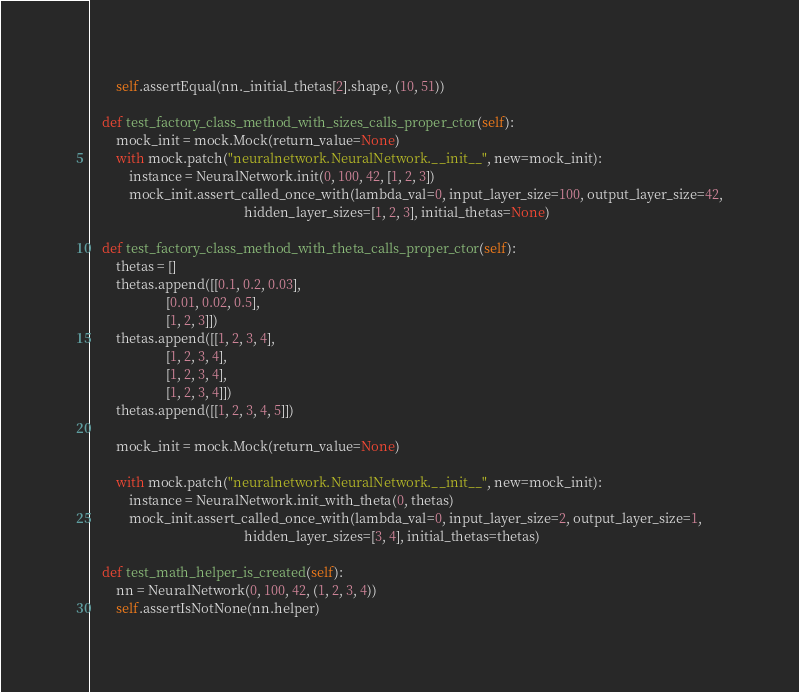Convert code to text. <code><loc_0><loc_0><loc_500><loc_500><_Python_>        self.assertEqual(nn._initial_thetas[2].shape, (10, 51))

    def test_factory_class_method_with_sizes_calls_proper_ctor(self):
        mock_init = mock.Mock(return_value=None)
        with mock.patch("neuralnetwork.NeuralNetwork.__init__", new=mock_init):
            instance = NeuralNetwork.init(0, 100, 42, [1, 2, 3])
            mock_init.assert_called_once_with(lambda_val=0, input_layer_size=100, output_layer_size=42,
                                              hidden_layer_sizes=[1, 2, 3], initial_thetas=None)

    def test_factory_class_method_with_theta_calls_proper_ctor(self):
        thetas = []
        thetas.append([[0.1, 0.2, 0.03],
                       [0.01, 0.02, 0.5],
                       [1, 2, 3]])
        thetas.append([[1, 2, 3, 4],
                       [1, 2, 3, 4],
                       [1, 2, 3, 4],
                       [1, 2, 3, 4]])
        thetas.append([[1, 2, 3, 4, 5]])

        mock_init = mock.Mock(return_value=None)

        with mock.patch("neuralnetwork.NeuralNetwork.__init__", new=mock_init):
            instance = NeuralNetwork.init_with_theta(0, thetas)
            mock_init.assert_called_once_with(lambda_val=0, input_layer_size=2, output_layer_size=1,
                                              hidden_layer_sizes=[3, 4], initial_thetas=thetas)

    def test_math_helper_is_created(self):
        nn = NeuralNetwork(0, 100, 42, (1, 2, 3, 4))
        self.assertIsNotNone(nn.helper)
</code> 